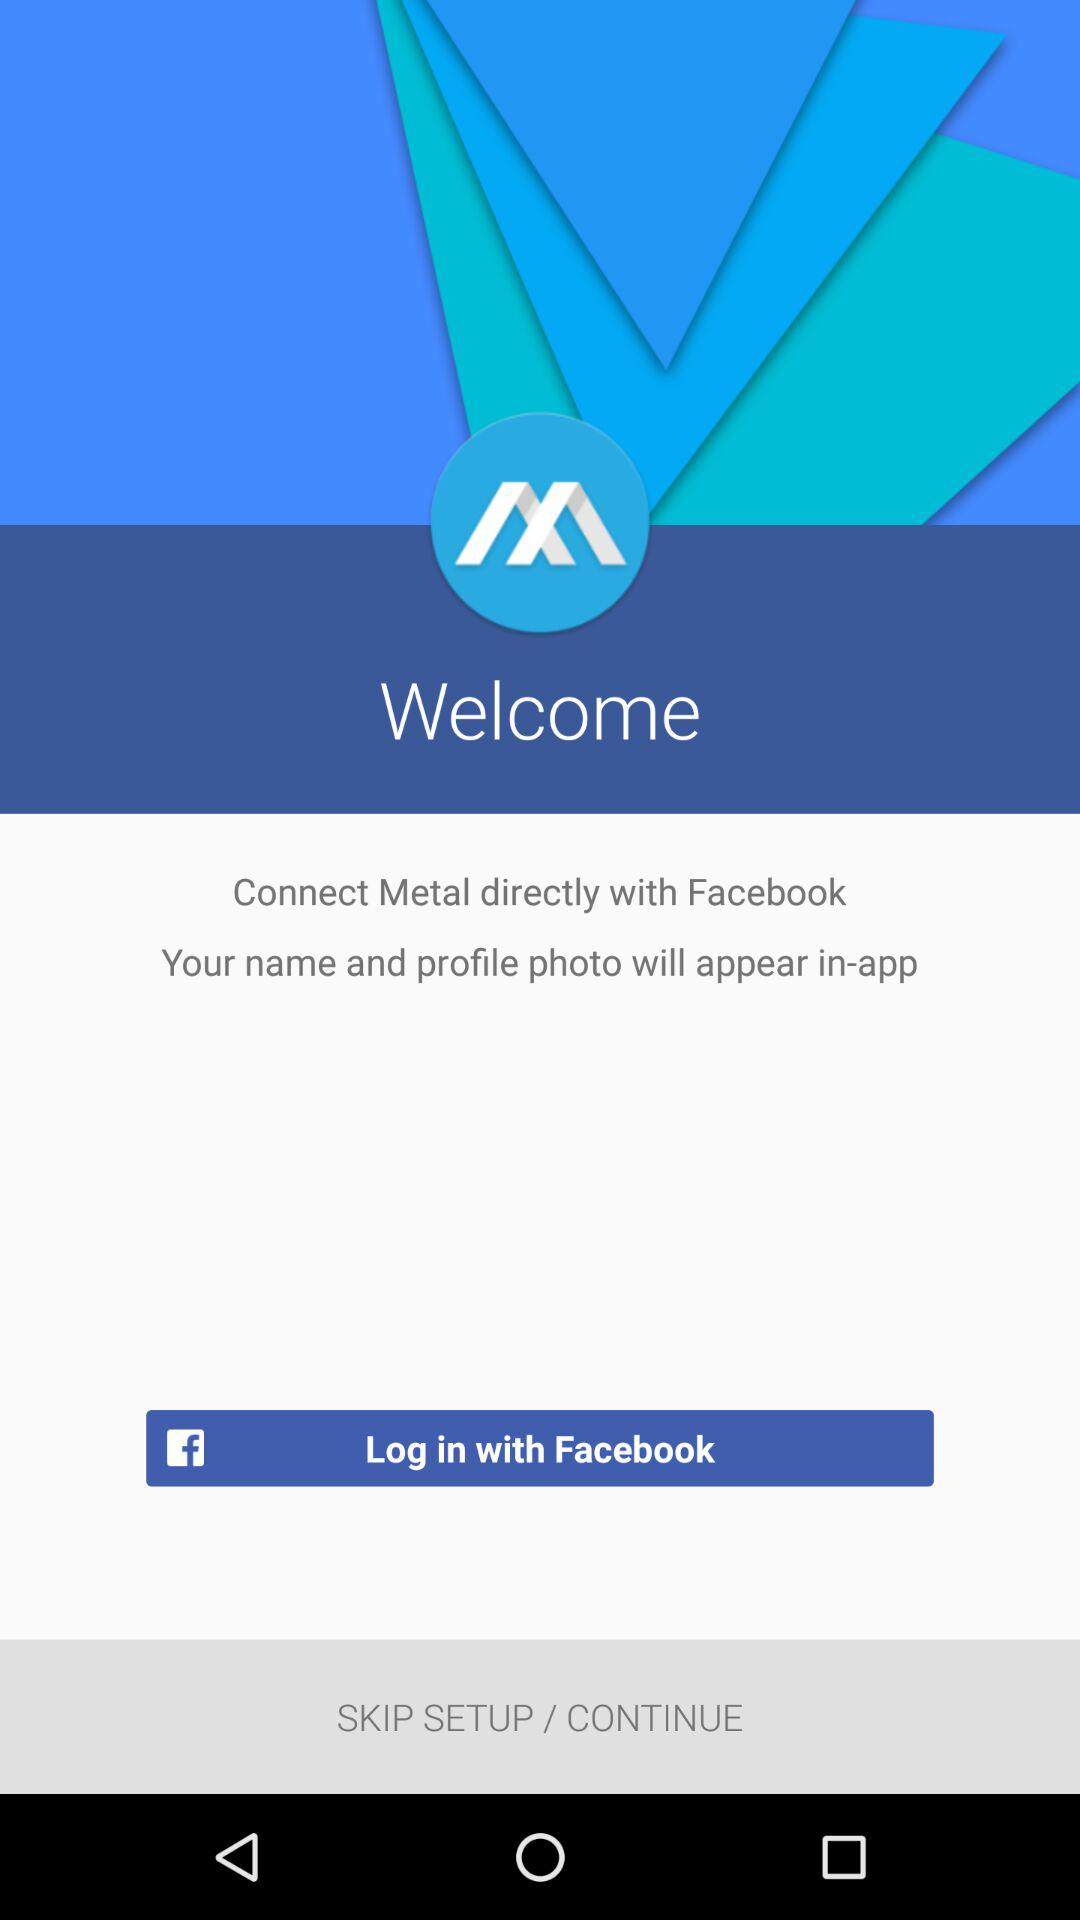What is the version of this application?
When the provided information is insufficient, respond with <no answer>. <no answer> 